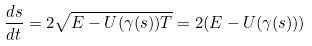Convert formula to latex. <formula><loc_0><loc_0><loc_500><loc_500>\frac { d s } { d t } = 2 \sqrt { E - U ( { \gamma } ( s ) ) T } = 2 ( E - U ( \gamma ( s ) ) )</formula> 